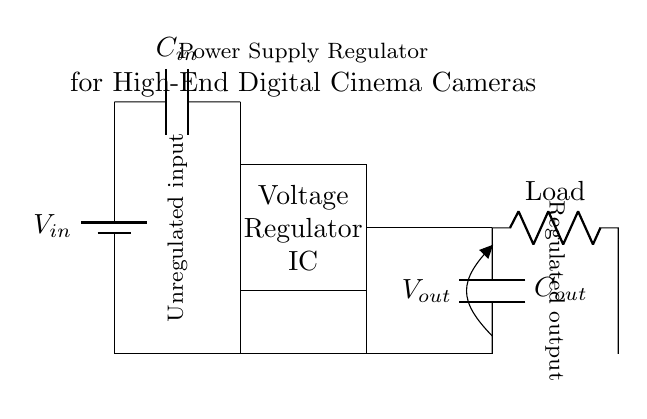What is the input voltage of this circuit? The input voltage is represented as \( V_{in} \) in the circuit diagram. It is indicated by the battery symbol at the top left corner, which supplies power to the circuit.
Answer: \( V_{in} \) What component regulates the voltage in this circuit? The component that regulates the voltage is labeled as "Voltage Regulator IC" in the diagram. It is situated in the rectangular box at the center, indicating its role in converting and stabilizing the input voltage.
Answer: Voltage Regulator IC What is the purpose of the output capacitor? The output capacitor, labeled as \( C_{out} \), is used to smooth the output voltage by filtering out any voltage ripples produced during regulation. It is connected to the output side of the voltage regulator to provide a stable output.
Answer: Smooth output voltage How many capacitors are present in this circuit? The circuit contains two capacitors: \( C_{in} \), connected at the input, and \( C_{out} \), connected at the output. They are crucial for stabilizing the input and output voltages respectively.
Answer: 2 What is the load connected to the output of the regulator? The load connected to the output is represented as "Load" in the diagram, indicating that it is the component that will use the regulated output voltage provided by the voltage regulator.
Answer: Load What is the function of the input capacitor in this circuit? The input capacitor, labeled as \( C_{in} \), serves to filter and stabilize the incoming voltage to the voltage regulator. It helps to prevent voltage spikes and noise from reaching the regulator, enhancing the quality of the output.
Answer: Stabilize input voltage What type of configuration does this circuit represent? This circuit represents a linear voltage regulator configuration, where a regulator IC maintains a consistent output voltage through a linear process, providing high-quality power for sensitive devices.
Answer: Linear voltage regulator 